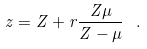Convert formula to latex. <formula><loc_0><loc_0><loc_500><loc_500>z = Z + r \frac { Z \mu } { Z - \mu } \ .</formula> 